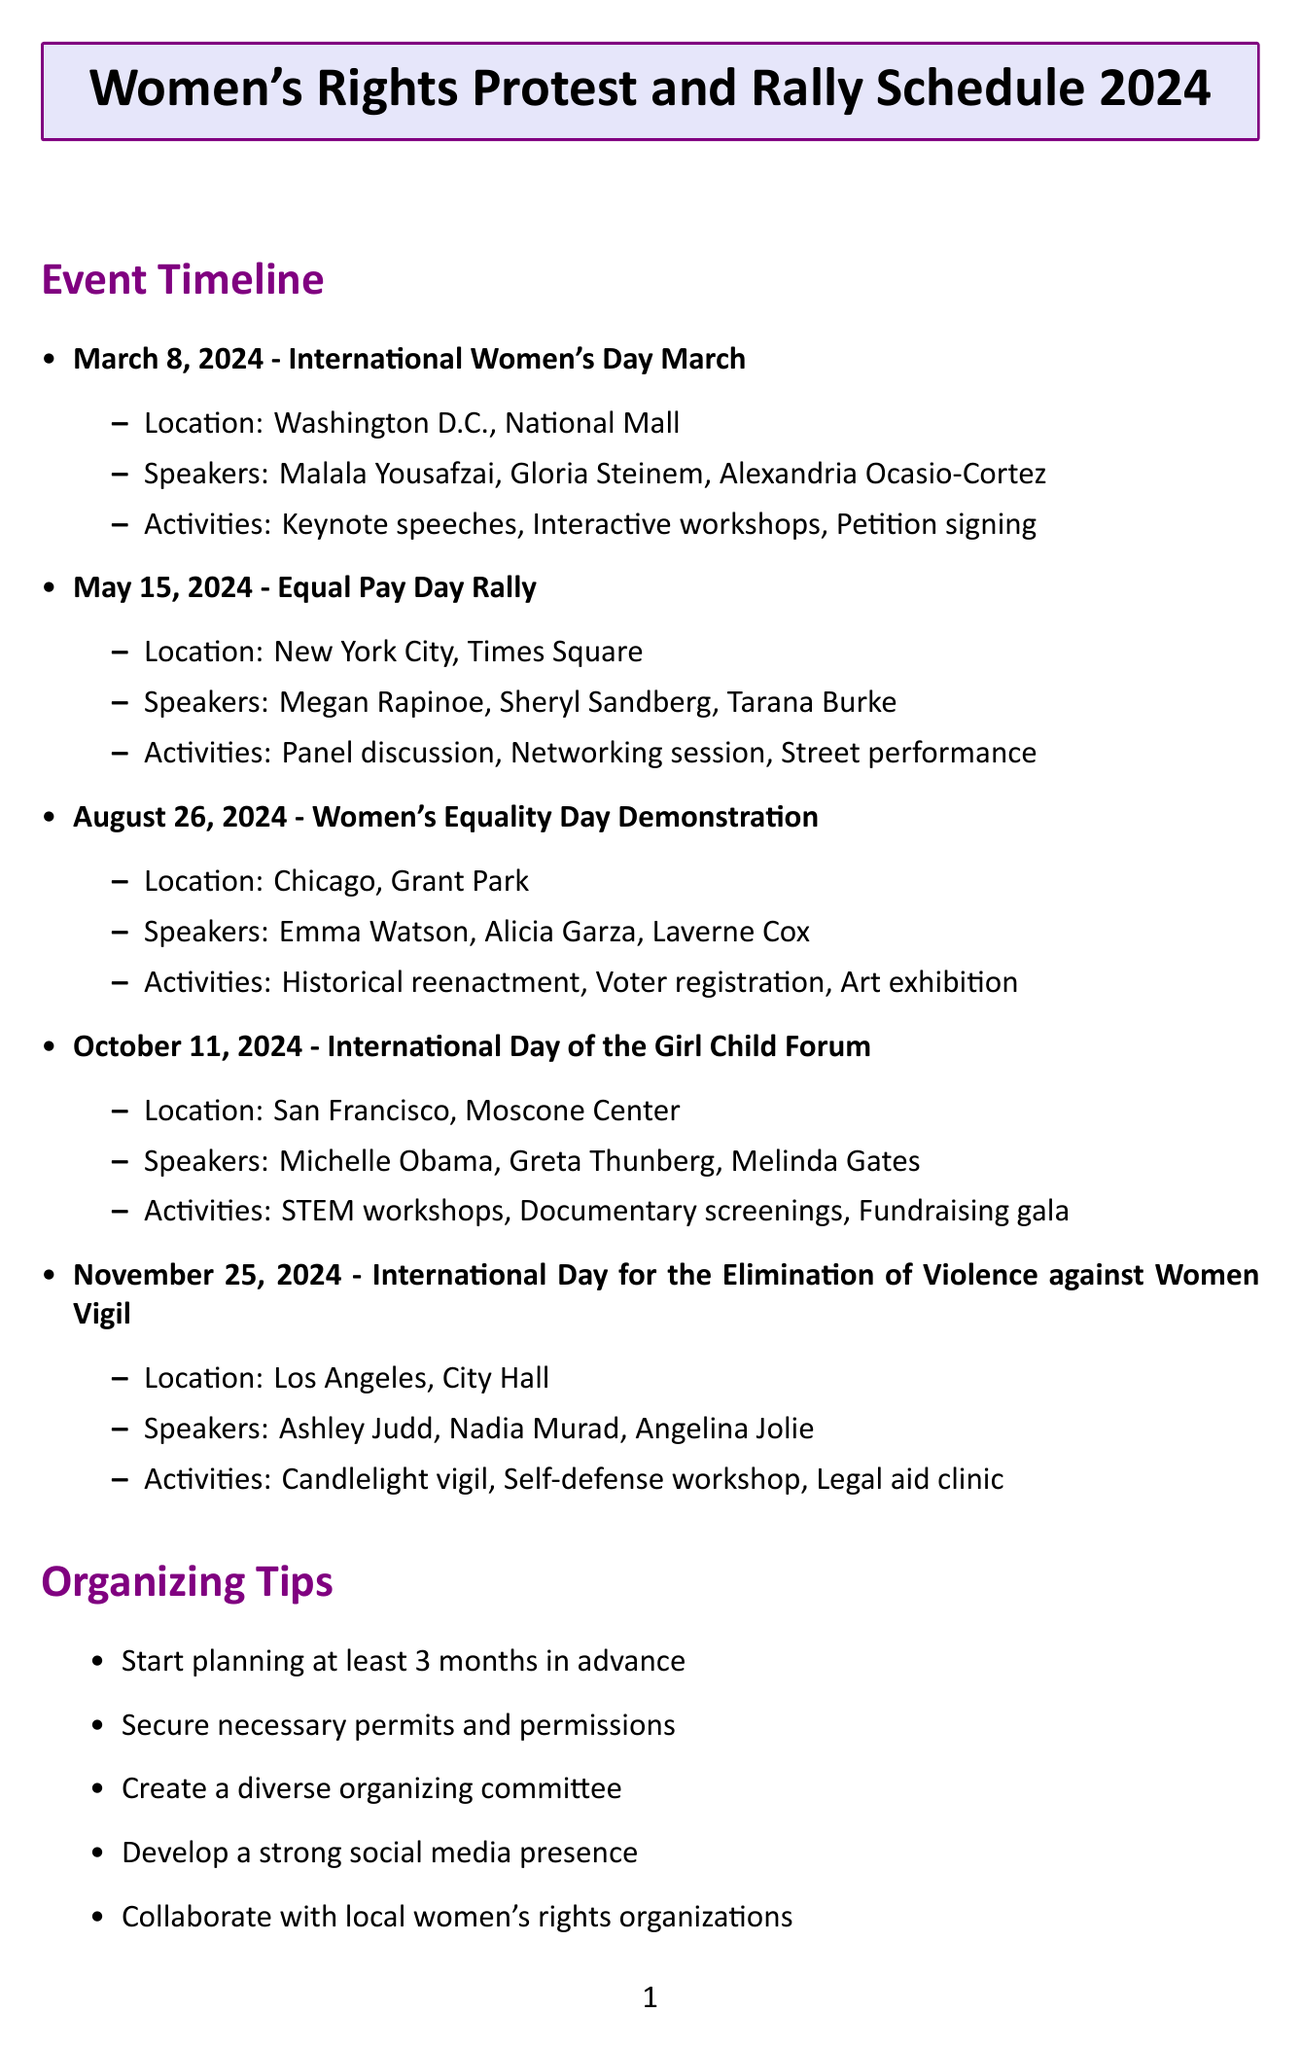What is the date of the International Women's Day March? The date is specifically mentioned in the timeline for the event International Women's Day March.
Answer: March 8, 2024 Where is the Equal Pay Day Rally taking place? The location for the Equal Pay Day Rally is listed in the event timeline.
Answer: New York City, Times Square Who is one of the speakers at the Women's Equality Day Demonstration? The document lists speakers for each event, including the Women's Equality Day Demonstration.
Answer: Emma Watson What activity is scheduled for the International Day of the Girl Child Forum? The activities are outlined in the document for the International Day of the Girl Child Forum.
Answer: STEM workshops for young girls How many events are listed in the protest timeline? The total number of events can be counted from the timeline.
Answer: Five Which organizing tip emphasizes collaboration? The organizing tips include various suggestions, one of which discusses collaboration.
Answer: Collaborate with local women's rights organizations What fundraising idea involves female artists? The document lists several fundraising ideas, including one that features female artists.
Answer: Benefit concert featuring female artists What is one outreach strategy mentioned? The outreach strategies include various methods, one of which can be highlighted.
Answer: Partner with universities and student organizations 